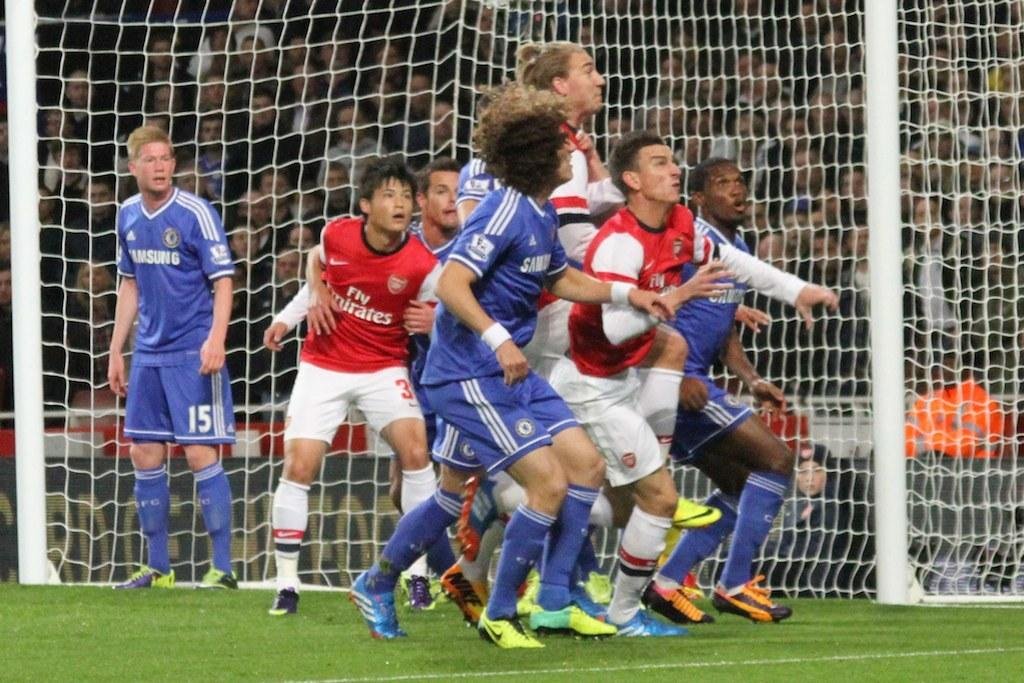<image>
Describe the image concisely. several Emirates and Samsung soccer players looking up in front of the goal 